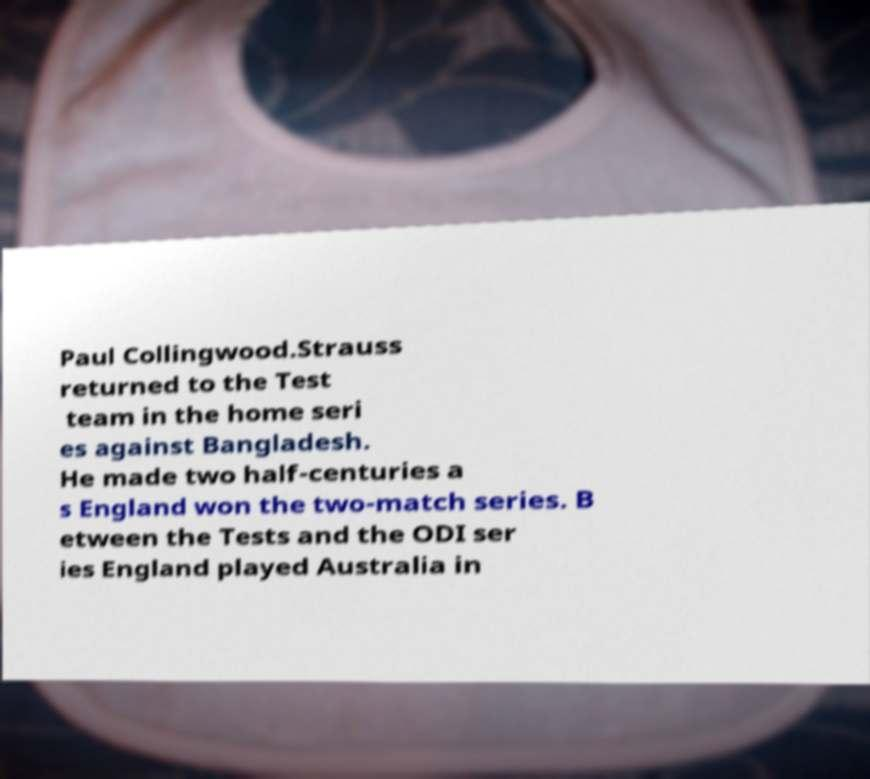Can you read and provide the text displayed in the image?This photo seems to have some interesting text. Can you extract and type it out for me? Paul Collingwood.Strauss returned to the Test team in the home seri es against Bangladesh. He made two half-centuries a s England won the two-match series. B etween the Tests and the ODI ser ies England played Australia in 